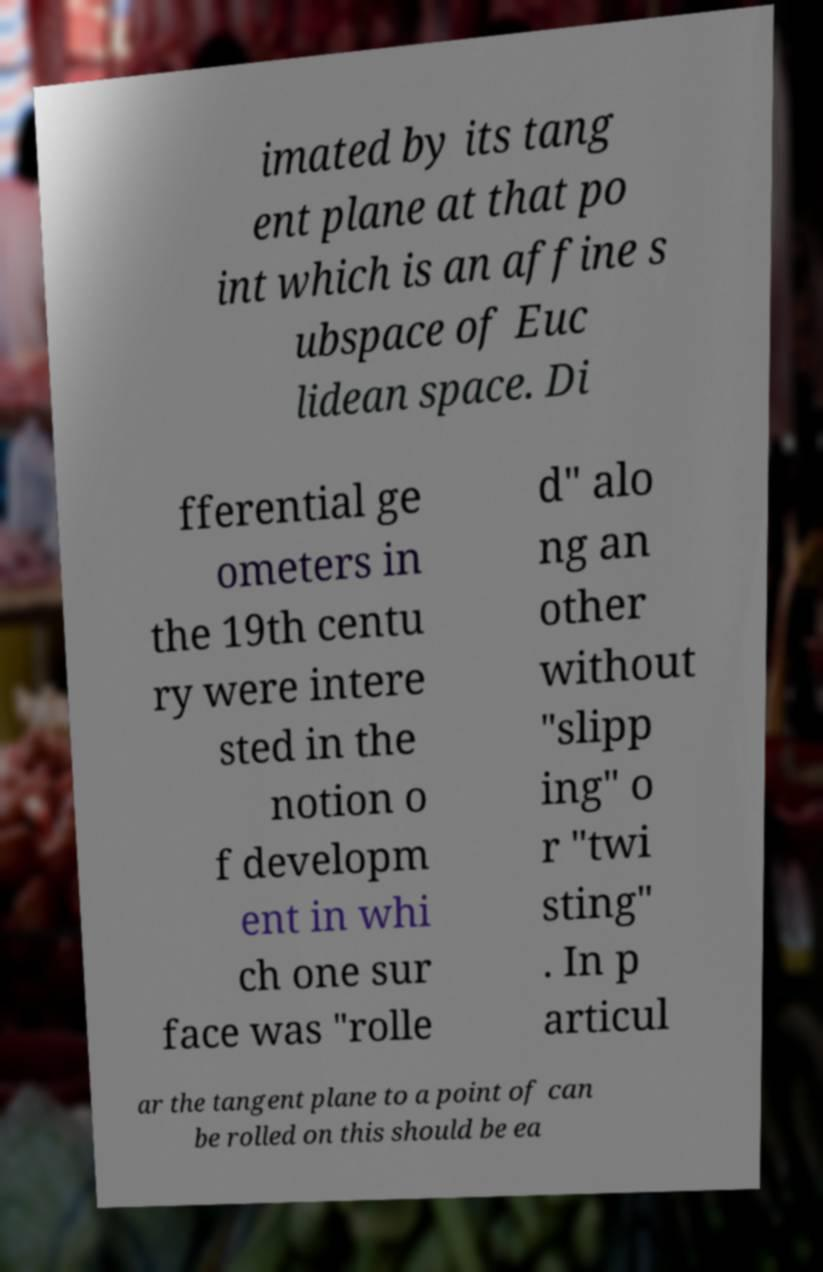There's text embedded in this image that I need extracted. Can you transcribe it verbatim? imated by its tang ent plane at that po int which is an affine s ubspace of Euc lidean space. Di fferential ge ometers in the 19th centu ry were intere sted in the notion o f developm ent in whi ch one sur face was "rolle d" alo ng an other without "slipp ing" o r "twi sting" . In p articul ar the tangent plane to a point of can be rolled on this should be ea 